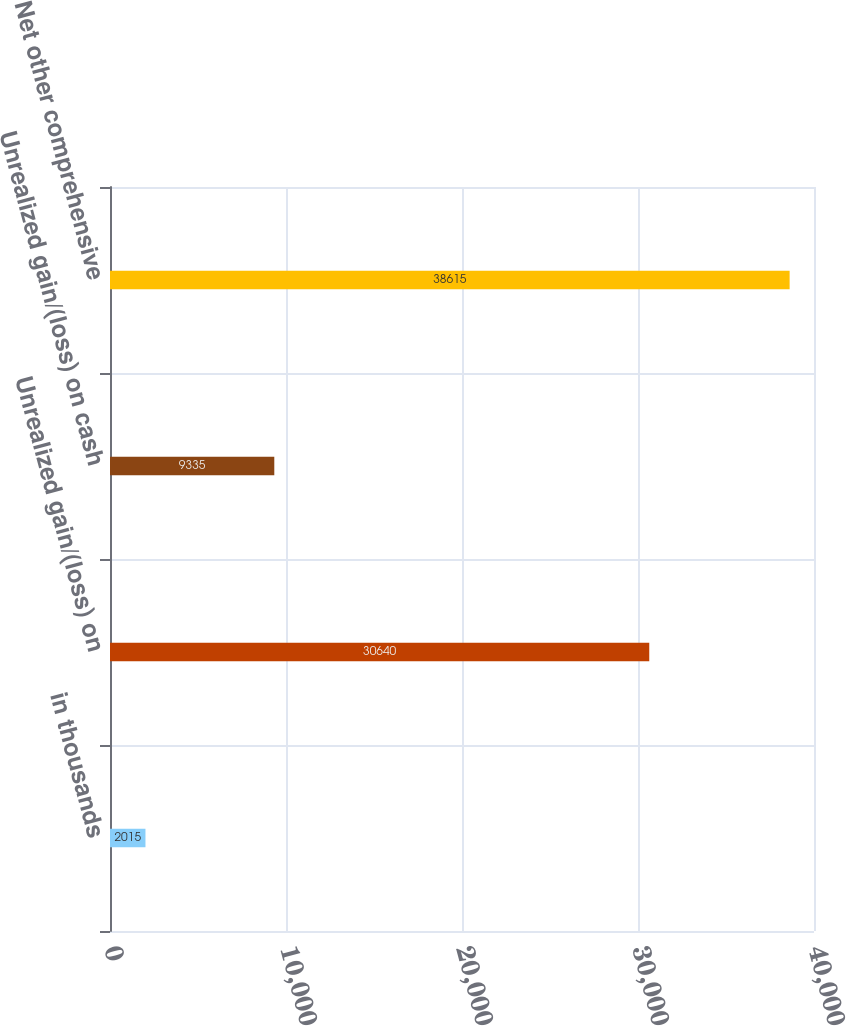<chart> <loc_0><loc_0><loc_500><loc_500><bar_chart><fcel>in thousands<fcel>Unrealized gain/(loss) on<fcel>Unrealized gain/(loss) on cash<fcel>Net other comprehensive<nl><fcel>2015<fcel>30640<fcel>9335<fcel>38615<nl></chart> 